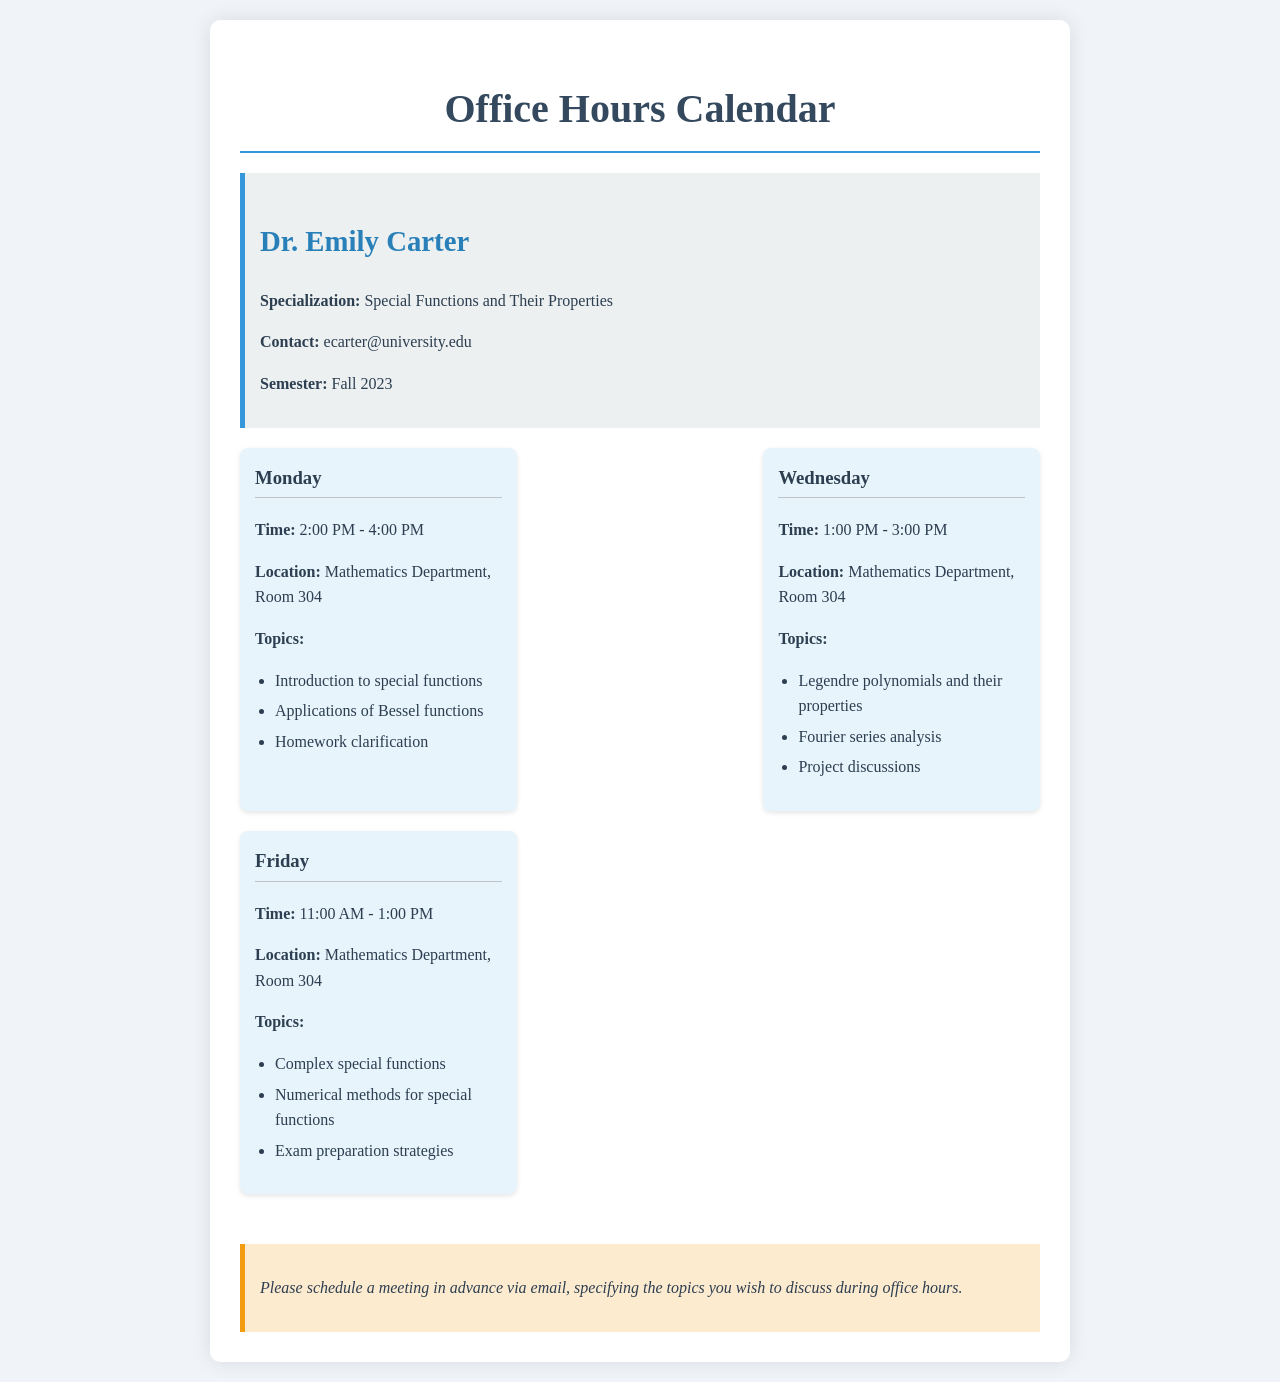What are Dr. Emily Carter's office hours on Monday? The document specifies that Dr. Emily Carter has office hours on Monday from 2:00 PM to 4:00 PM.
Answer: 2:00 PM - 4:00 PM What is the location for office hours? The document mentions that all office hours are held in the Mathematics Department, Room 304.
Answer: Mathematics Department, Room 304 Which topic is discussed on Wednesday? The document lists Legendre polynomials and their properties as one of the topics discussed on Wednesday during office hours.
Answer: Legendre polynomials and their properties How many days are designated for office hours? The document outlines office hours for three different days: Monday, Wednesday, and Friday.
Answer: Three What is the specialization of Dr. Emily Carter? The document states that Dr. Emily Carter specializes in Special Functions and Their Properties.
Answer: Special Functions and Their Properties What is the time slot for office hours on Friday? According to the document, the office hours on Friday are from 11:00 AM to 1:00 PM.
Answer: 11:00 AM - 1:00 PM What should students do before attending office hours? The document advises students to schedule a meeting in advance via email before coming to office hours.
Answer: Schedule a meeting in advance via email What type of functions is discussed on Monday? The document specifies that applications of Bessel functions are one of the topics discussed on Monday during office hours.
Answer: Bessel functions What is the note regarding scheduling meetings? The note in the document emphasizes the importance of specifying the topics of discussion in the email when scheduling office hours.
Answer: Specify the topics you wish to discuss during office hours 